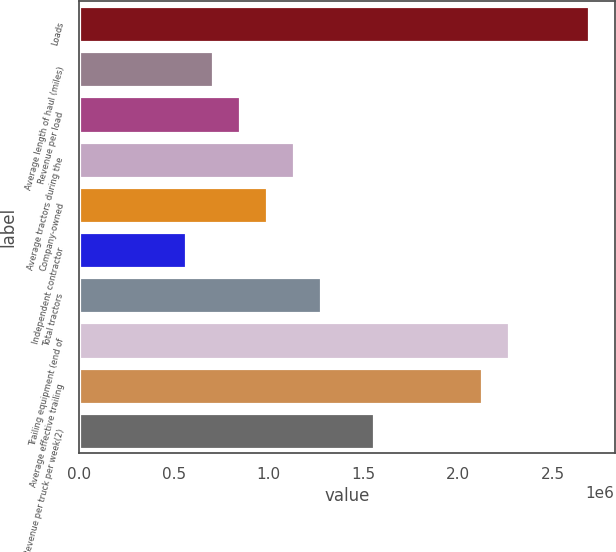<chart> <loc_0><loc_0><loc_500><loc_500><bar_chart><fcel>Loads<fcel>Average length of haul (miles)<fcel>Revenue per load<fcel>Average tractors during the<fcel>Company-owned<fcel>Independent contractor<fcel>Total tractors<fcel>Trailing equipment (end of<fcel>Average effective trailing<fcel>Revenue per truck per week(2)<nl><fcel>2.68975e+06<fcel>707838<fcel>849403<fcel>1.13253e+06<fcel>990968<fcel>566273<fcel>1.2741e+06<fcel>2.26505e+06<fcel>2.12349e+06<fcel>1.55723e+06<nl></chart> 